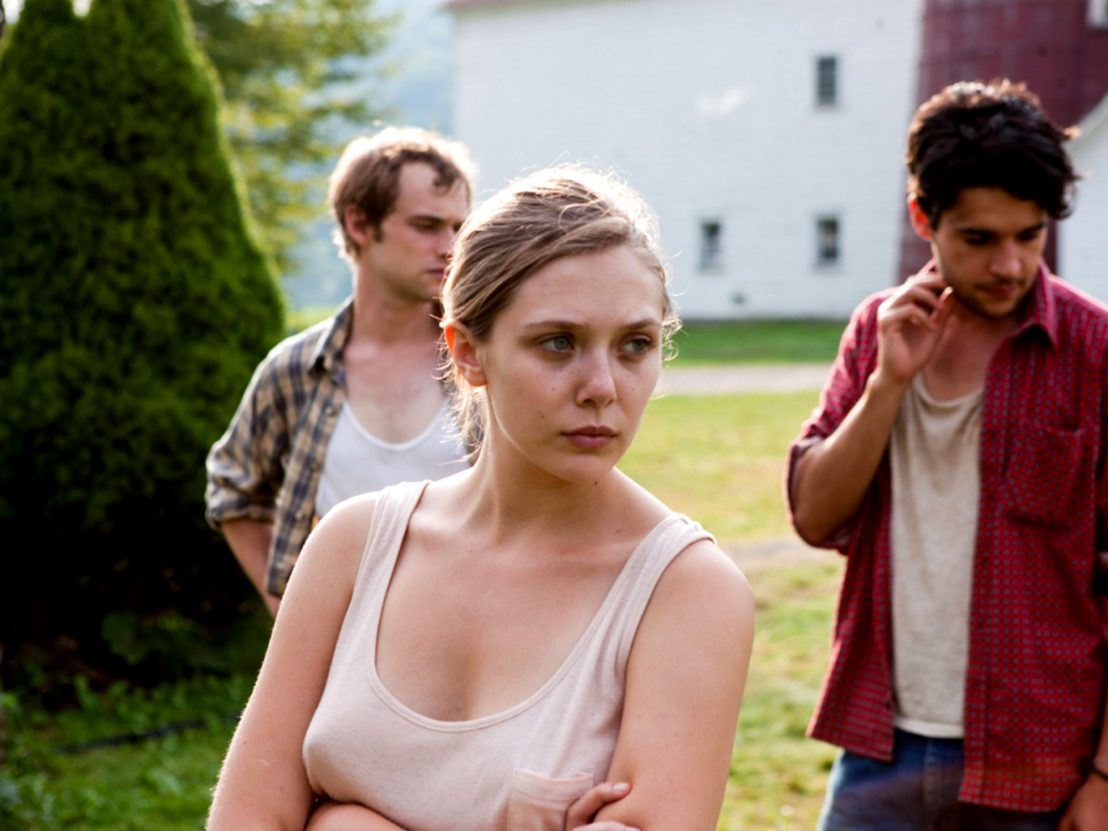What's happening in the scene? In this image, a prominent actress stands at the center with her arms crossed, her expression conveying deep concern as she gazes off to the side. The scene around her paints a rustic, rural picture with a red barn in the background and a large tree to the left adding to the setting's bucolic charm. She is flanked by two men: one to her left wearing a plaid shirt and appearing somewhat disheveled, and the other to her right in a red shirt, scratching his head as if in thought or hesitation. The setting suggests an intense moment, possibly filled with tension or contemplation, amidst the tranquil country backdrop. The muted colors, contrasted by the vibrant red of the barn and the greenery, heighten the emotional weight of the scene. 